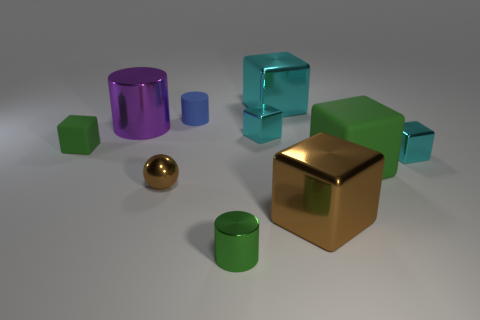Are there any large matte cubes in front of the large green cube?
Make the answer very short. No. What number of objects are small metal things to the right of the green metallic cylinder or big cyan spheres?
Give a very brief answer. 2. What number of blue things are either metallic objects or rubber blocks?
Ensure brevity in your answer.  0. What number of other things are there of the same color as the big metallic cylinder?
Keep it short and to the point. 0. Are there fewer brown metal things to the left of the big brown metal block than cylinders?
Make the answer very short. Yes. There is a tiny cylinder behind the metal cylinder in front of the sphere that is left of the small green shiny object; what is its color?
Provide a succinct answer. Blue. There is a green object that is the same shape as the blue thing; what is its size?
Give a very brief answer. Small. Are there fewer large metal cylinders right of the big purple thing than brown shiny blocks that are to the right of the large green matte thing?
Provide a short and direct response. No. There is a object that is both left of the brown block and in front of the tiny shiny sphere; what shape is it?
Provide a short and direct response. Cylinder. What size is the ball that is made of the same material as the large brown cube?
Give a very brief answer. Small. 